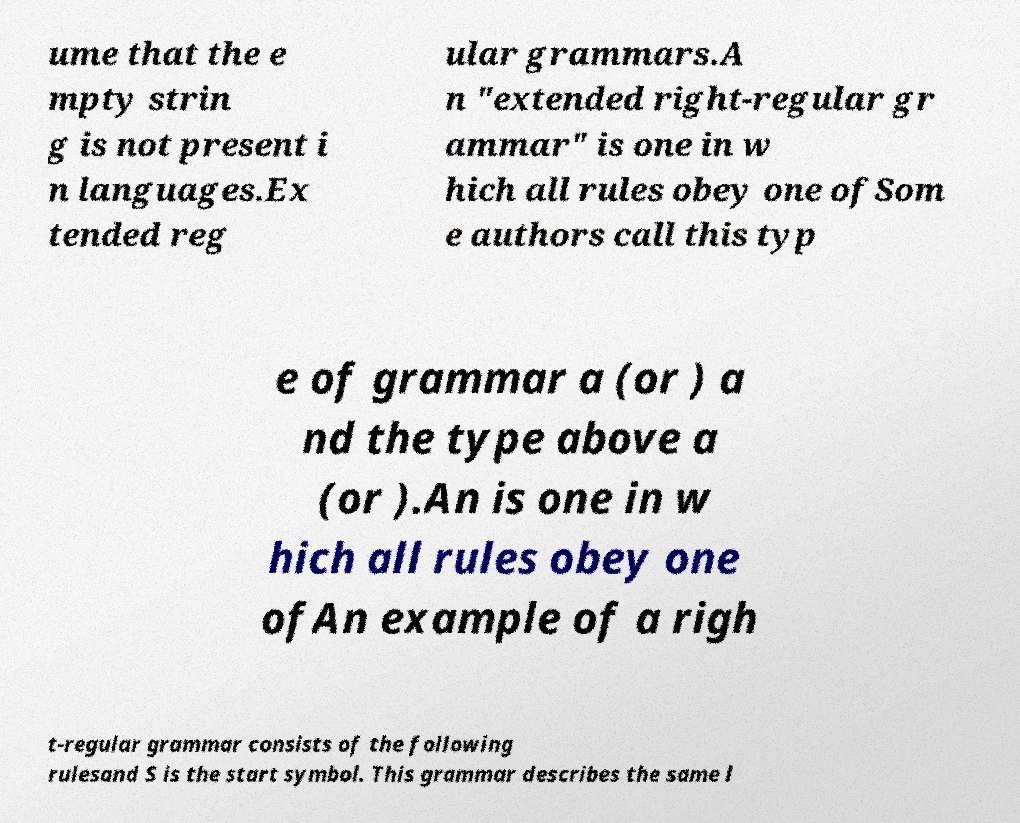Could you extract and type out the text from this image? ume that the e mpty strin g is not present i n languages.Ex tended reg ular grammars.A n "extended right-regular gr ammar" is one in w hich all rules obey one ofSom e authors call this typ e of grammar a (or ) a nd the type above a (or ).An is one in w hich all rules obey one ofAn example of a righ t-regular grammar consists of the following rulesand S is the start symbol. This grammar describes the same l 